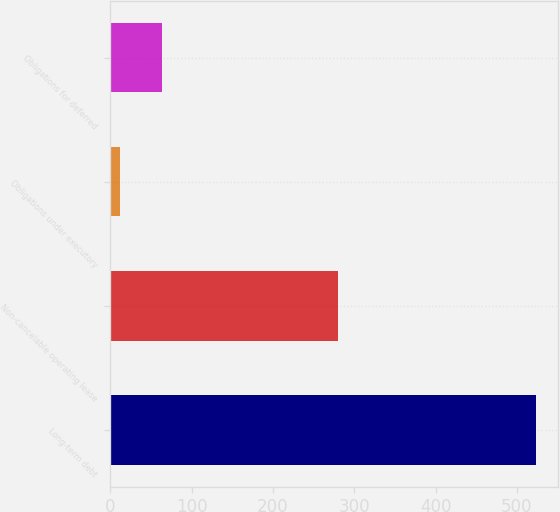<chart> <loc_0><loc_0><loc_500><loc_500><bar_chart><fcel>Long-term debt<fcel>Non-cancelable operating lease<fcel>Obligations under executory<fcel>Obligations for deferred<nl><fcel>523.8<fcel>279.9<fcel>11.3<fcel>64<nl></chart> 